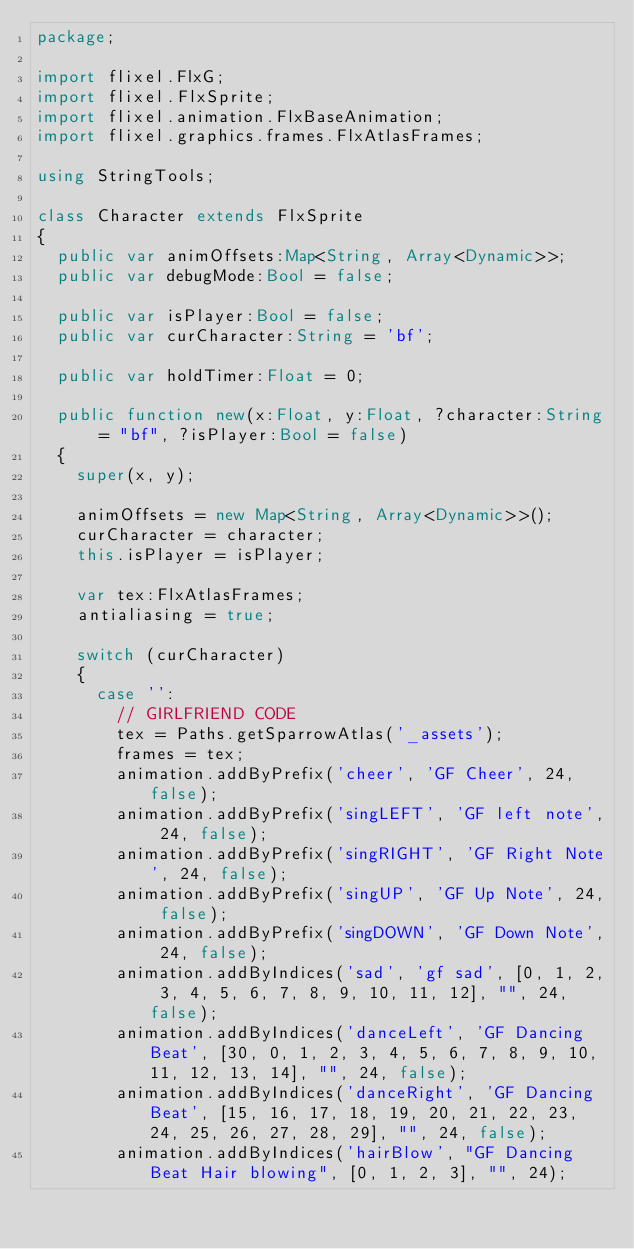Convert code to text. <code><loc_0><loc_0><loc_500><loc_500><_Haxe_>package;

import flixel.FlxG;
import flixel.FlxSprite;
import flixel.animation.FlxBaseAnimation;
import flixel.graphics.frames.FlxAtlasFrames;

using StringTools;

class Character extends FlxSprite
{
	public var animOffsets:Map<String, Array<Dynamic>>;
	public var debugMode:Bool = false;

	public var isPlayer:Bool = false;
	public var curCharacter:String = 'bf';

	public var holdTimer:Float = 0;

	public function new(x:Float, y:Float, ?character:String = "bf", ?isPlayer:Bool = false)
	{
		super(x, y);

		animOffsets = new Map<String, Array<Dynamic>>();
		curCharacter = character;
		this.isPlayer = isPlayer;

		var tex:FlxAtlasFrames;
		antialiasing = true;

		switch (curCharacter)
		{
			case '':
				// GIRLFRIEND CODE
				tex = Paths.getSparrowAtlas('_assets');
				frames = tex;
				animation.addByPrefix('cheer', 'GF Cheer', 24, false);
				animation.addByPrefix('singLEFT', 'GF left note', 24, false);
				animation.addByPrefix('singRIGHT', 'GF Right Note', 24, false);
				animation.addByPrefix('singUP', 'GF Up Note', 24, false);
				animation.addByPrefix('singDOWN', 'GF Down Note', 24, false);
				animation.addByIndices('sad', 'gf sad', [0, 1, 2, 3, 4, 5, 6, 7, 8, 9, 10, 11, 12], "", 24, false);
				animation.addByIndices('danceLeft', 'GF Dancing Beat', [30, 0, 1, 2, 3, 4, 5, 6, 7, 8, 9, 10, 11, 12, 13, 14], "", 24, false);
				animation.addByIndices('danceRight', 'GF Dancing Beat', [15, 16, 17, 18, 19, 20, 21, 22, 23, 24, 25, 26, 27, 28, 29], "", 24, false);
				animation.addByIndices('hairBlow', "GF Dancing Beat Hair blowing", [0, 1, 2, 3], "", 24);</code> 